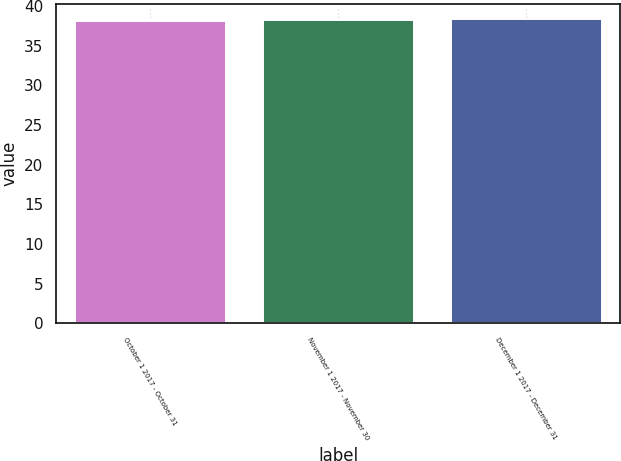Convert chart. <chart><loc_0><loc_0><loc_500><loc_500><bar_chart><fcel>October 1 2017 - October 31<fcel>November 1 2017 - November 30<fcel>December 1 2017 - December 31<nl><fcel>38.18<fcel>38.28<fcel>38.38<nl></chart> 